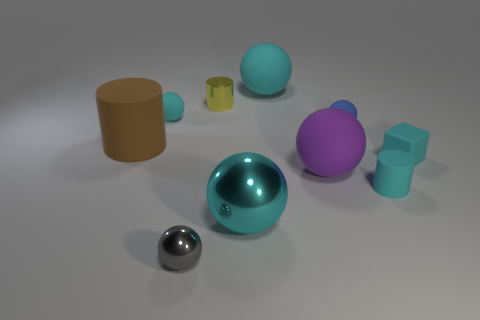How many cyan spheres must be subtracted to get 1 cyan spheres? 2 Subtract all green cylinders. How many cyan balls are left? 3 Subtract all blue balls. How many balls are left? 5 Subtract all small cyan rubber spheres. How many spheres are left? 5 Subtract all yellow spheres. Subtract all green blocks. How many spheres are left? 6 Subtract all blocks. How many objects are left? 9 Subtract all tiny metal things. Subtract all large rubber things. How many objects are left? 5 Add 3 large cyan rubber balls. How many large cyan rubber balls are left? 4 Add 5 blue metallic things. How many blue metallic things exist? 5 Subtract 0 red cubes. How many objects are left? 10 